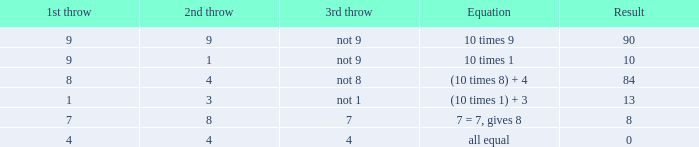If the expression is (10 x 1) + 3, what is the second throw? 3.0. Parse the table in full. {'header': ['1st throw', '2nd throw', '3rd throw', 'Equation', 'Result'], 'rows': [['9', '9', 'not 9', '10 times 9', '90'], ['9', '1', 'not 9', '10 times 1', '10'], ['8', '4', 'not 8', '(10 times 8) + 4', '84'], ['1', '3', 'not 1', '(10 times 1) + 3', '13'], ['7', '8', '7', '7 = 7, gives 8', '8'], ['4', '4', '4', 'all equal', '0']]} 